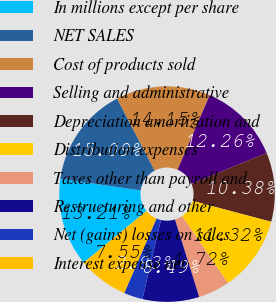<chart> <loc_0><loc_0><loc_500><loc_500><pie_chart><fcel>In millions except per share<fcel>NET SALES<fcel>Cost of products sold<fcel>Selling and administrative<fcel>Depreciation amortization and<fcel>Distribution expenses<fcel>Taxes other than payroll and<fcel>Restructuring and other<fcel>Net (gains) losses on sales<fcel>Interest expense net<nl><fcel>13.21%<fcel>15.09%<fcel>14.15%<fcel>12.26%<fcel>10.38%<fcel>11.32%<fcel>4.72%<fcel>8.49%<fcel>2.83%<fcel>7.55%<nl></chart> 